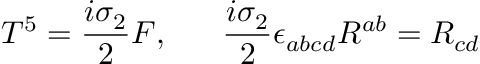<formula> <loc_0><loc_0><loc_500><loc_500>T ^ { 5 } = { \frac { i \sigma _ { 2 } } { 2 } } F , \quad \ { \frac { i \sigma _ { 2 } } { 2 } } \epsilon _ { a b c d } R ^ { a b } = R _ { c d }</formula> 